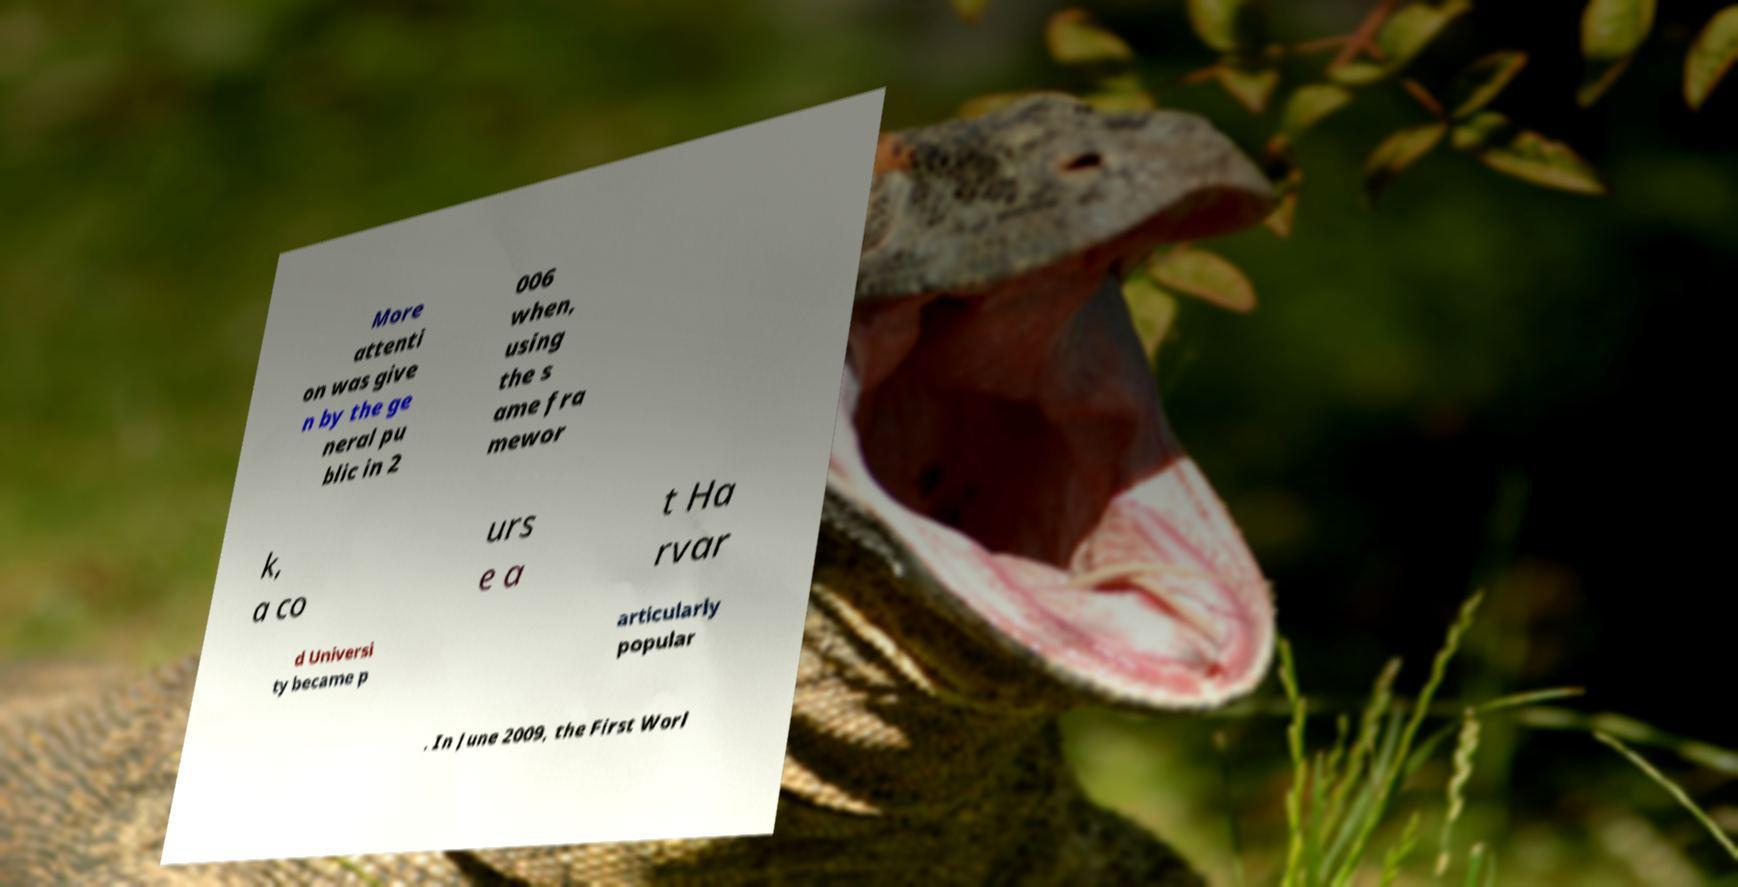Could you assist in decoding the text presented in this image and type it out clearly? More attenti on was give n by the ge neral pu blic in 2 006 when, using the s ame fra mewor k, a co urs e a t Ha rvar d Universi ty became p articularly popular . In June 2009, the First Worl 